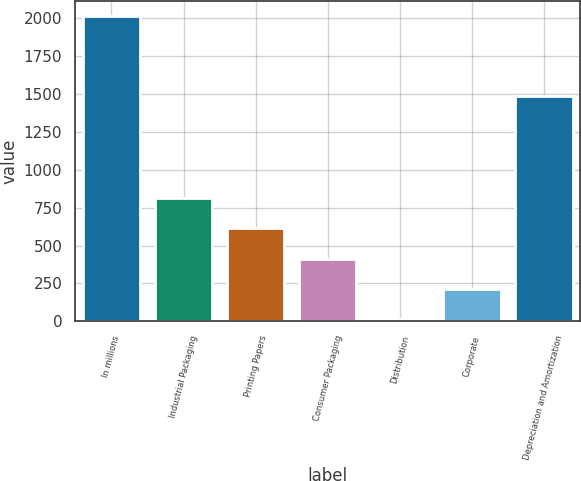<chart> <loc_0><loc_0><loc_500><loc_500><bar_chart><fcel>In millions<fcel>Industrial Packaging<fcel>Printing Papers<fcel>Consumer Packaging<fcel>Distribution<fcel>Corporate<fcel>Depreciation and Amortization<nl><fcel>2012<fcel>812.6<fcel>612.7<fcel>412.8<fcel>13<fcel>212.9<fcel>1486<nl></chart> 